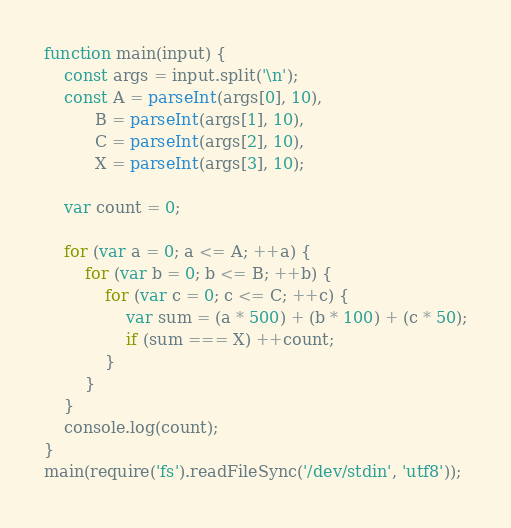<code> <loc_0><loc_0><loc_500><loc_500><_JavaScript_>function main(input) {
    const args = input.split('\n');
    const A = parseInt(args[0], 10),
          B = parseInt(args[1], 10),
          C = parseInt(args[2], 10),
          X = parseInt(args[3], 10);

    var count = 0;

    for (var a = 0; a <= A; ++a) {
        for (var b = 0; b <= B; ++b) {
            for (var c = 0; c <= C; ++c) {
                var sum = (a * 500) + (b * 100) + (c * 50);
                if (sum === X) ++count;
            }
        }
    }
    console.log(count);
}
main(require('fs').readFileSync('/dev/stdin', 'utf8'));</code> 